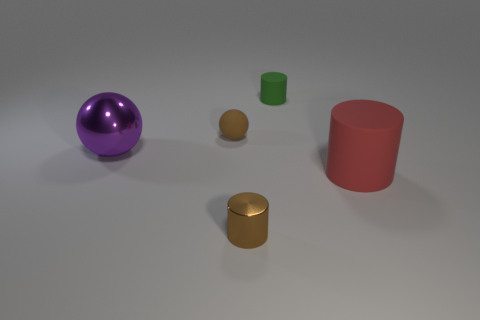Is there a large purple shiny thing on the right side of the rubber thing in front of the matte sphere behind the purple ball?
Your answer should be compact. No. There is a brown object that is the same size as the metallic cylinder; what shape is it?
Provide a short and direct response. Sphere. Does the rubber thing that is to the left of the shiny cylinder have the same size as the metal object in front of the big purple thing?
Keep it short and to the point. Yes. What number of tiny red cylinders are there?
Provide a succinct answer. 0. There is a matte object to the right of the green rubber object that is behind the big object that is on the left side of the red cylinder; what is its size?
Provide a succinct answer. Large. Is the rubber sphere the same color as the small metallic cylinder?
Give a very brief answer. Yes. There is a tiny brown ball; how many shiny cylinders are in front of it?
Make the answer very short. 1. Are there the same number of green cylinders that are in front of the small sphere and rubber cylinders?
Your answer should be very brief. No. What number of objects are small purple objects or cylinders?
Provide a short and direct response. 3. The brown thing in front of the small brown object that is on the left side of the brown cylinder is what shape?
Provide a succinct answer. Cylinder. 